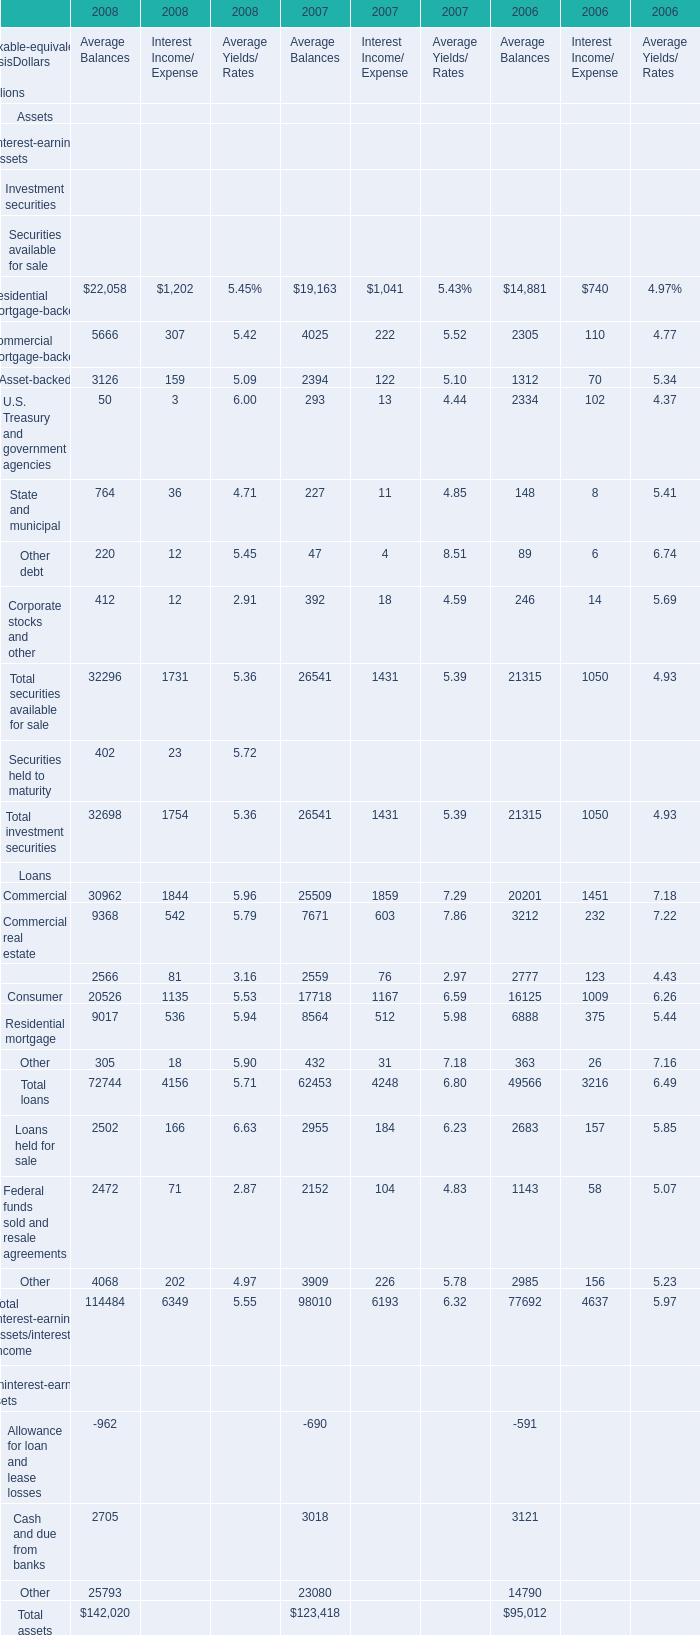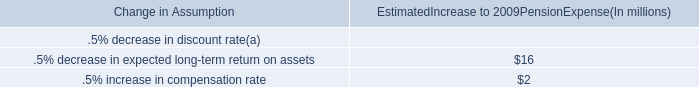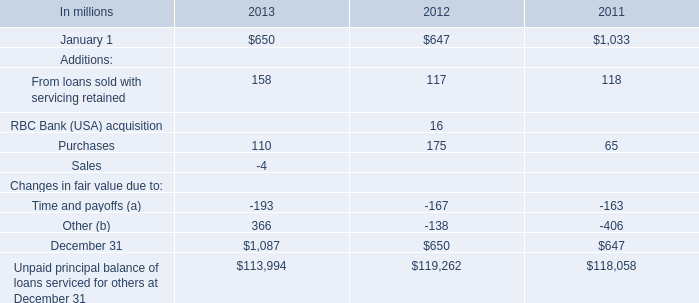In the year with lowest amount of Residential mortgage-backed for Average Balances?, what's the increasing rate of Cash and due from banks of Noninterest-earning assets 
Computations: ((2705 - 3018) / 2705)
Answer: -0.11571. 